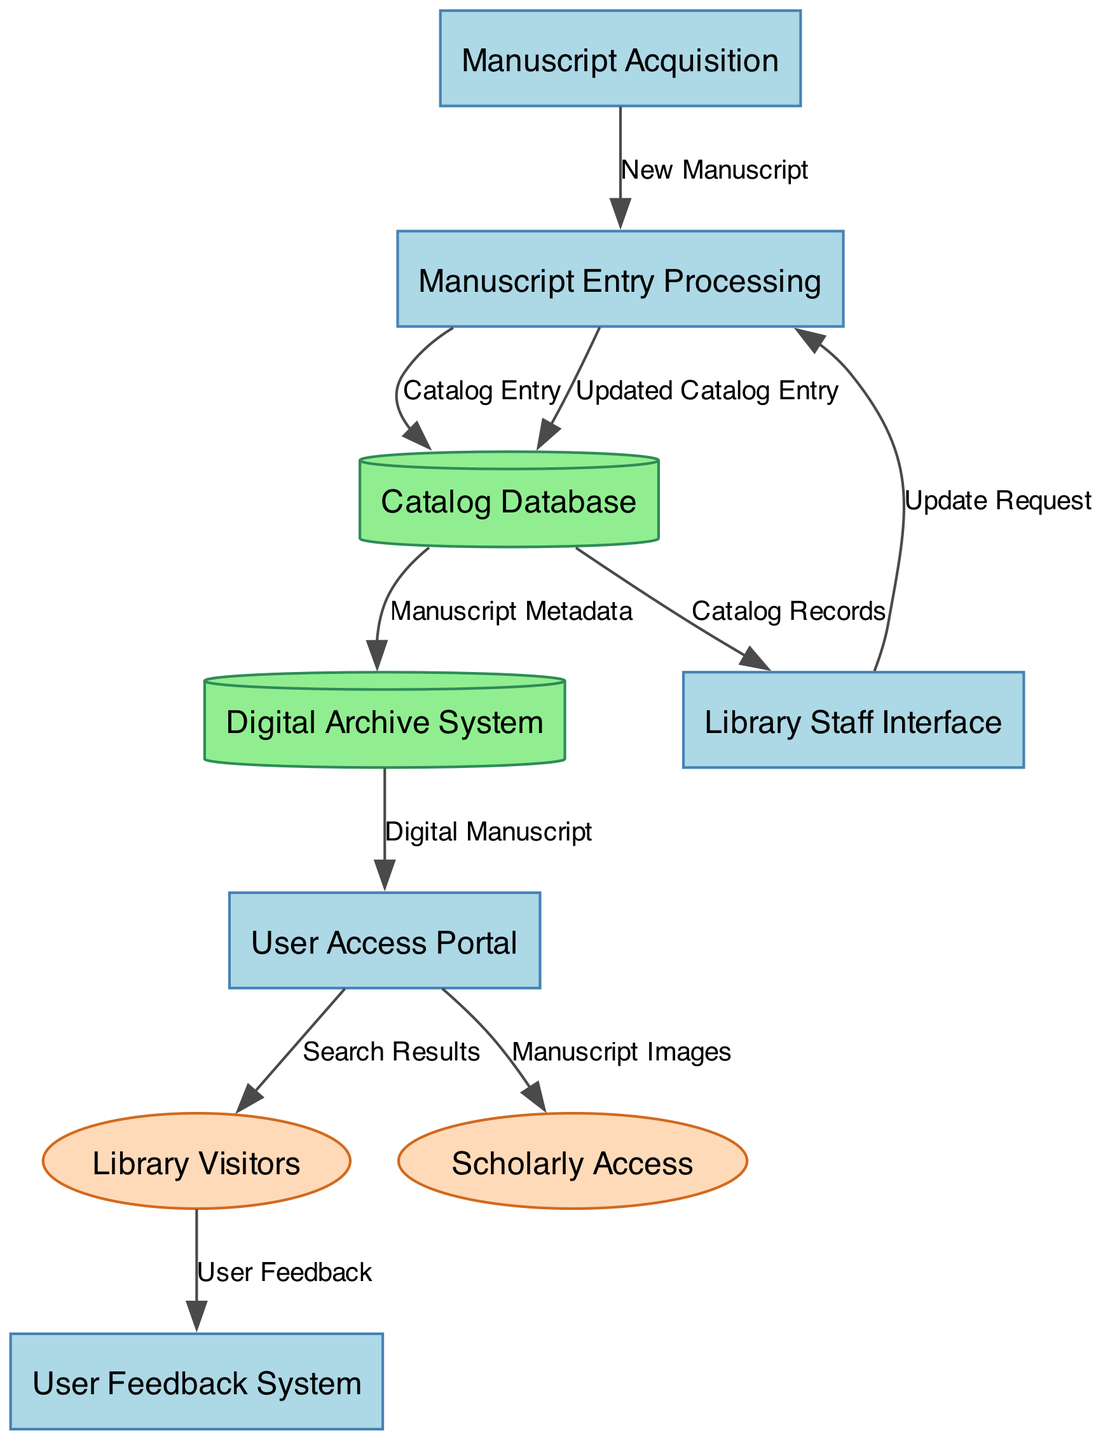What is the starting point for new manuscripts? The starting point for new manuscripts is the "Manuscript Acquisition" process. This process involves acquiring manuscripts, which then flow into "Manuscript Entry Processing."
Answer: Manuscript Acquisition What data is transferred from "User Access Portal" to "Library Visitors"? The data transferred from "User Access Portal" to "Library Visitors" is "Search Results." This information assists library visitors in finding manuscripts.
Answer: Search Results How many distinct processes are depicted in the diagram? There are five distinct processes depicted in the diagram. They are "Manuscript Acquisition," "Manuscript Entry Processing," "User Access Portal," "Library Staff Interface," and "User Feedback System."
Answer: Five Which data store receives the output of "Manuscript Entry Processing"? The output from "Manuscript Entry Processing" goes to the "Catalog Database." This database holds the catalog entries created during the processing of manuscripts.
Answer: Catalog Database What is the purpose of the "User Feedback System"? The purpose of the "User Feedback System" is to collect and manage feedback from "Library Visitors." This process helps to gather input on user experiences and suggestions.
Answer: Collect and manage feedback Which process provides access to high-resolution manuscript images? The "User Access Portal" provides access to high-resolution manuscript images specifically to "Scholarly Access." This is tailored for scholars needing detailed views of manuscripts.
Answer: User Access Portal Which entities interact with the "Digital Archive System"? The "Digital Archive System" interacts with the "User Access Portal," providing "Digital Manuscript" data for the users accessing manuscripts digitally.
Answer: User Access Portal What type of data is stored in the "Digital Archive System"? The "Digital Archive System" stores "Manuscript Metadata" along with manuscript images. This metadata includes details about the manuscripts that aid in their identification and classification.
Answer: Manuscript Metadata How is the "Catalog Database" updated? The "Catalog Database" is updated through requests from the "Library Staff Interface," specifically via the "Update Request" data flow, which leads to an "Updated Catalog Entry."
Answer: Update Request 